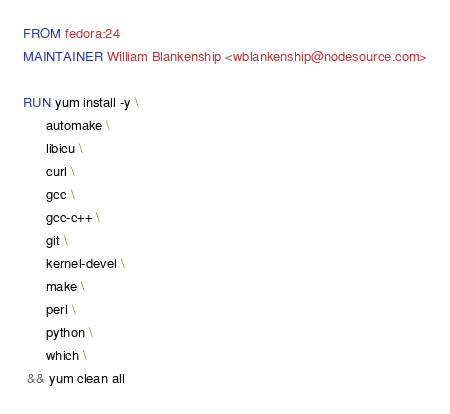Convert code to text. <code><loc_0><loc_0><loc_500><loc_500><_Dockerfile_>FROM fedora:24
MAINTAINER William Blankenship <wblankenship@nodesource.com>

RUN yum install -y \
      automake \
      libicu \
      curl \
      gcc \
      gcc-c++ \
      git \
      kernel-devel \
      make \
      perl \
      python \
      which \
 && yum clean all

</code> 